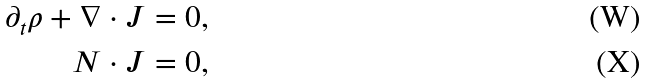Convert formula to latex. <formula><loc_0><loc_0><loc_500><loc_500>\partial _ { t } \rho + { \nabla \cdot J } & = 0 , \\ { N \cdot J } & = 0 ,</formula> 